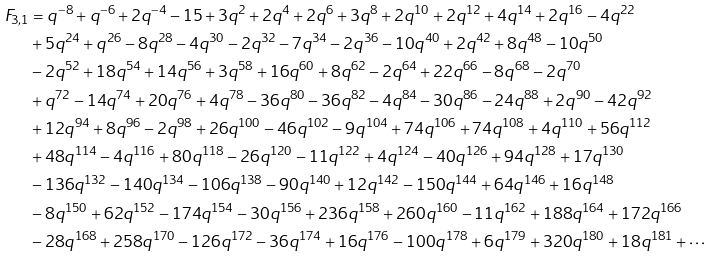<formula> <loc_0><loc_0><loc_500><loc_500>F _ { 3 , 1 } & = q ^ { - 8 } + q ^ { - 6 } + 2 q ^ { - 4 } - 1 5 + 3 q ^ { 2 } + 2 q ^ { 4 } + 2 q ^ { 6 } + 3 q ^ { 8 } + 2 q ^ { 1 0 } + 2 q ^ { 1 2 } + 4 q ^ { 1 4 } + 2 q ^ { 1 6 } - 4 q ^ { 2 2 } \\ & + 5 q ^ { 2 4 } + q ^ { 2 6 } - 8 q ^ { 2 8 } - 4 q ^ { 3 0 } - 2 q ^ { 3 2 } - 7 q ^ { 3 4 } - 2 q ^ { 3 6 } - 1 0 q ^ { 4 0 } + 2 q ^ { 4 2 } + 8 q ^ { 4 8 } - 1 0 q ^ { 5 0 } \\ & - 2 q ^ { 5 2 } + 1 8 q ^ { 5 4 } + 1 4 q ^ { 5 6 } + 3 q ^ { 5 8 } + 1 6 q ^ { 6 0 } + 8 q ^ { 6 2 } - 2 q ^ { 6 4 } + 2 2 q ^ { 6 6 } - 8 q ^ { 6 8 } - 2 q ^ { 7 0 } \\ & + q ^ { 7 2 } - 1 4 q ^ { 7 4 } + 2 0 q ^ { 7 6 } + 4 q ^ { 7 8 } - 3 6 q ^ { 8 0 } - 3 6 q ^ { 8 2 } - 4 q ^ { 8 4 } - 3 0 q ^ { 8 6 } - 2 4 q ^ { 8 8 } + 2 q ^ { 9 0 } - 4 2 q ^ { 9 2 } \\ & + 1 2 q ^ { 9 4 } + 8 q ^ { 9 6 } - 2 q ^ { 9 8 } + 2 6 q ^ { 1 0 0 } - 4 6 q ^ { 1 0 2 } - 9 q ^ { 1 0 4 } + 7 4 q ^ { 1 0 6 } + 7 4 q ^ { 1 0 8 } + 4 q ^ { 1 1 0 } + 5 6 q ^ { 1 1 2 } \\ & + 4 8 q ^ { 1 1 4 } - 4 q ^ { 1 1 6 } + 8 0 q ^ { 1 1 8 } - 2 6 q ^ { 1 2 0 } - 1 1 q ^ { 1 2 2 } + 4 q ^ { 1 2 4 } - 4 0 q ^ { 1 2 6 } + 9 4 q ^ { 1 2 8 } + 1 7 q ^ { 1 3 0 } \\ & - 1 3 6 q ^ { 1 3 2 } - 1 4 0 q ^ { 1 3 4 } - 1 0 6 q ^ { 1 3 8 } - 9 0 q ^ { 1 4 0 } + 1 2 q ^ { 1 4 2 } - 1 5 0 q ^ { 1 4 4 } + 6 4 q ^ { 1 4 6 } + 1 6 q ^ { 1 4 8 } \\ & - 8 q ^ { 1 5 0 } + 6 2 q ^ { 1 5 2 } - 1 7 4 q ^ { 1 5 4 } - 3 0 q ^ { 1 5 6 } + 2 3 6 q ^ { 1 5 8 } + 2 6 0 q ^ { 1 6 0 } - 1 1 q ^ { 1 6 2 } + 1 8 8 q ^ { 1 6 4 } + 1 7 2 q ^ { 1 6 6 } \\ & - 2 8 q ^ { 1 6 8 } + 2 5 8 q ^ { 1 7 0 } - 1 2 6 q ^ { 1 7 2 } - 3 6 q ^ { 1 7 4 } + 1 6 q ^ { 1 7 6 } - 1 0 0 q ^ { 1 7 8 } + 6 q ^ { 1 7 9 } + 3 2 0 q ^ { 1 8 0 } + 1 8 q ^ { 1 8 1 } + \cdots</formula> 